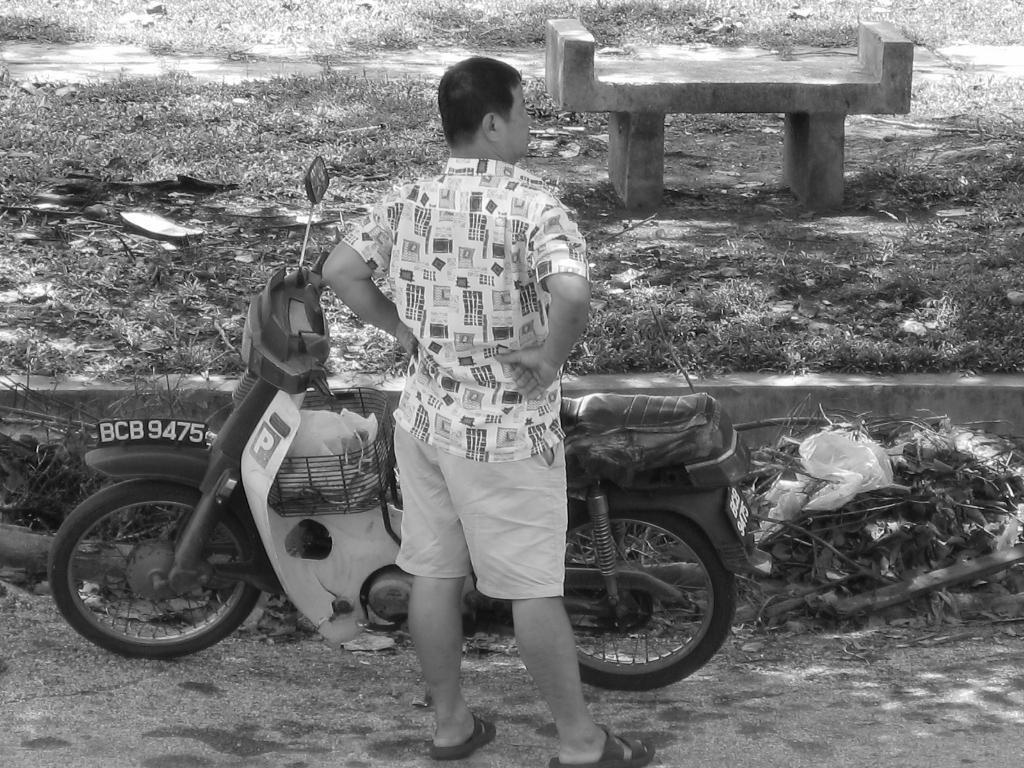Describe this image in one or two sentences. Here in this picture we can see a person standing on the ground and in front of him we can see a scooter present and we can see some part of ground is covered with grass and we can also see a bench present on the ground. 